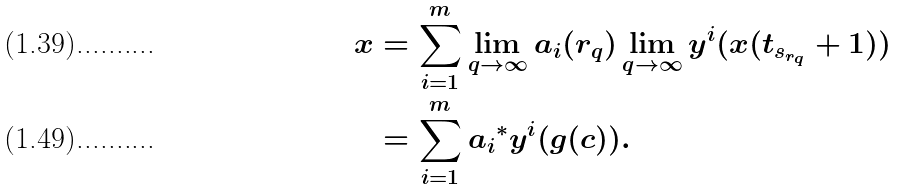<formula> <loc_0><loc_0><loc_500><loc_500>x & = \sum _ { i = 1 } ^ { m } \lim _ { q \to \infty } a _ { i } ( r _ { q } ) \lim _ { q \to \infty } y ^ { i } ( x ( t _ { s _ { r _ { q } } } + 1 ) ) \\ & = \sum _ { i = 1 } ^ { m } { a _ { i } } ^ { \ast } y ^ { i } ( g ( c ) ) .</formula> 